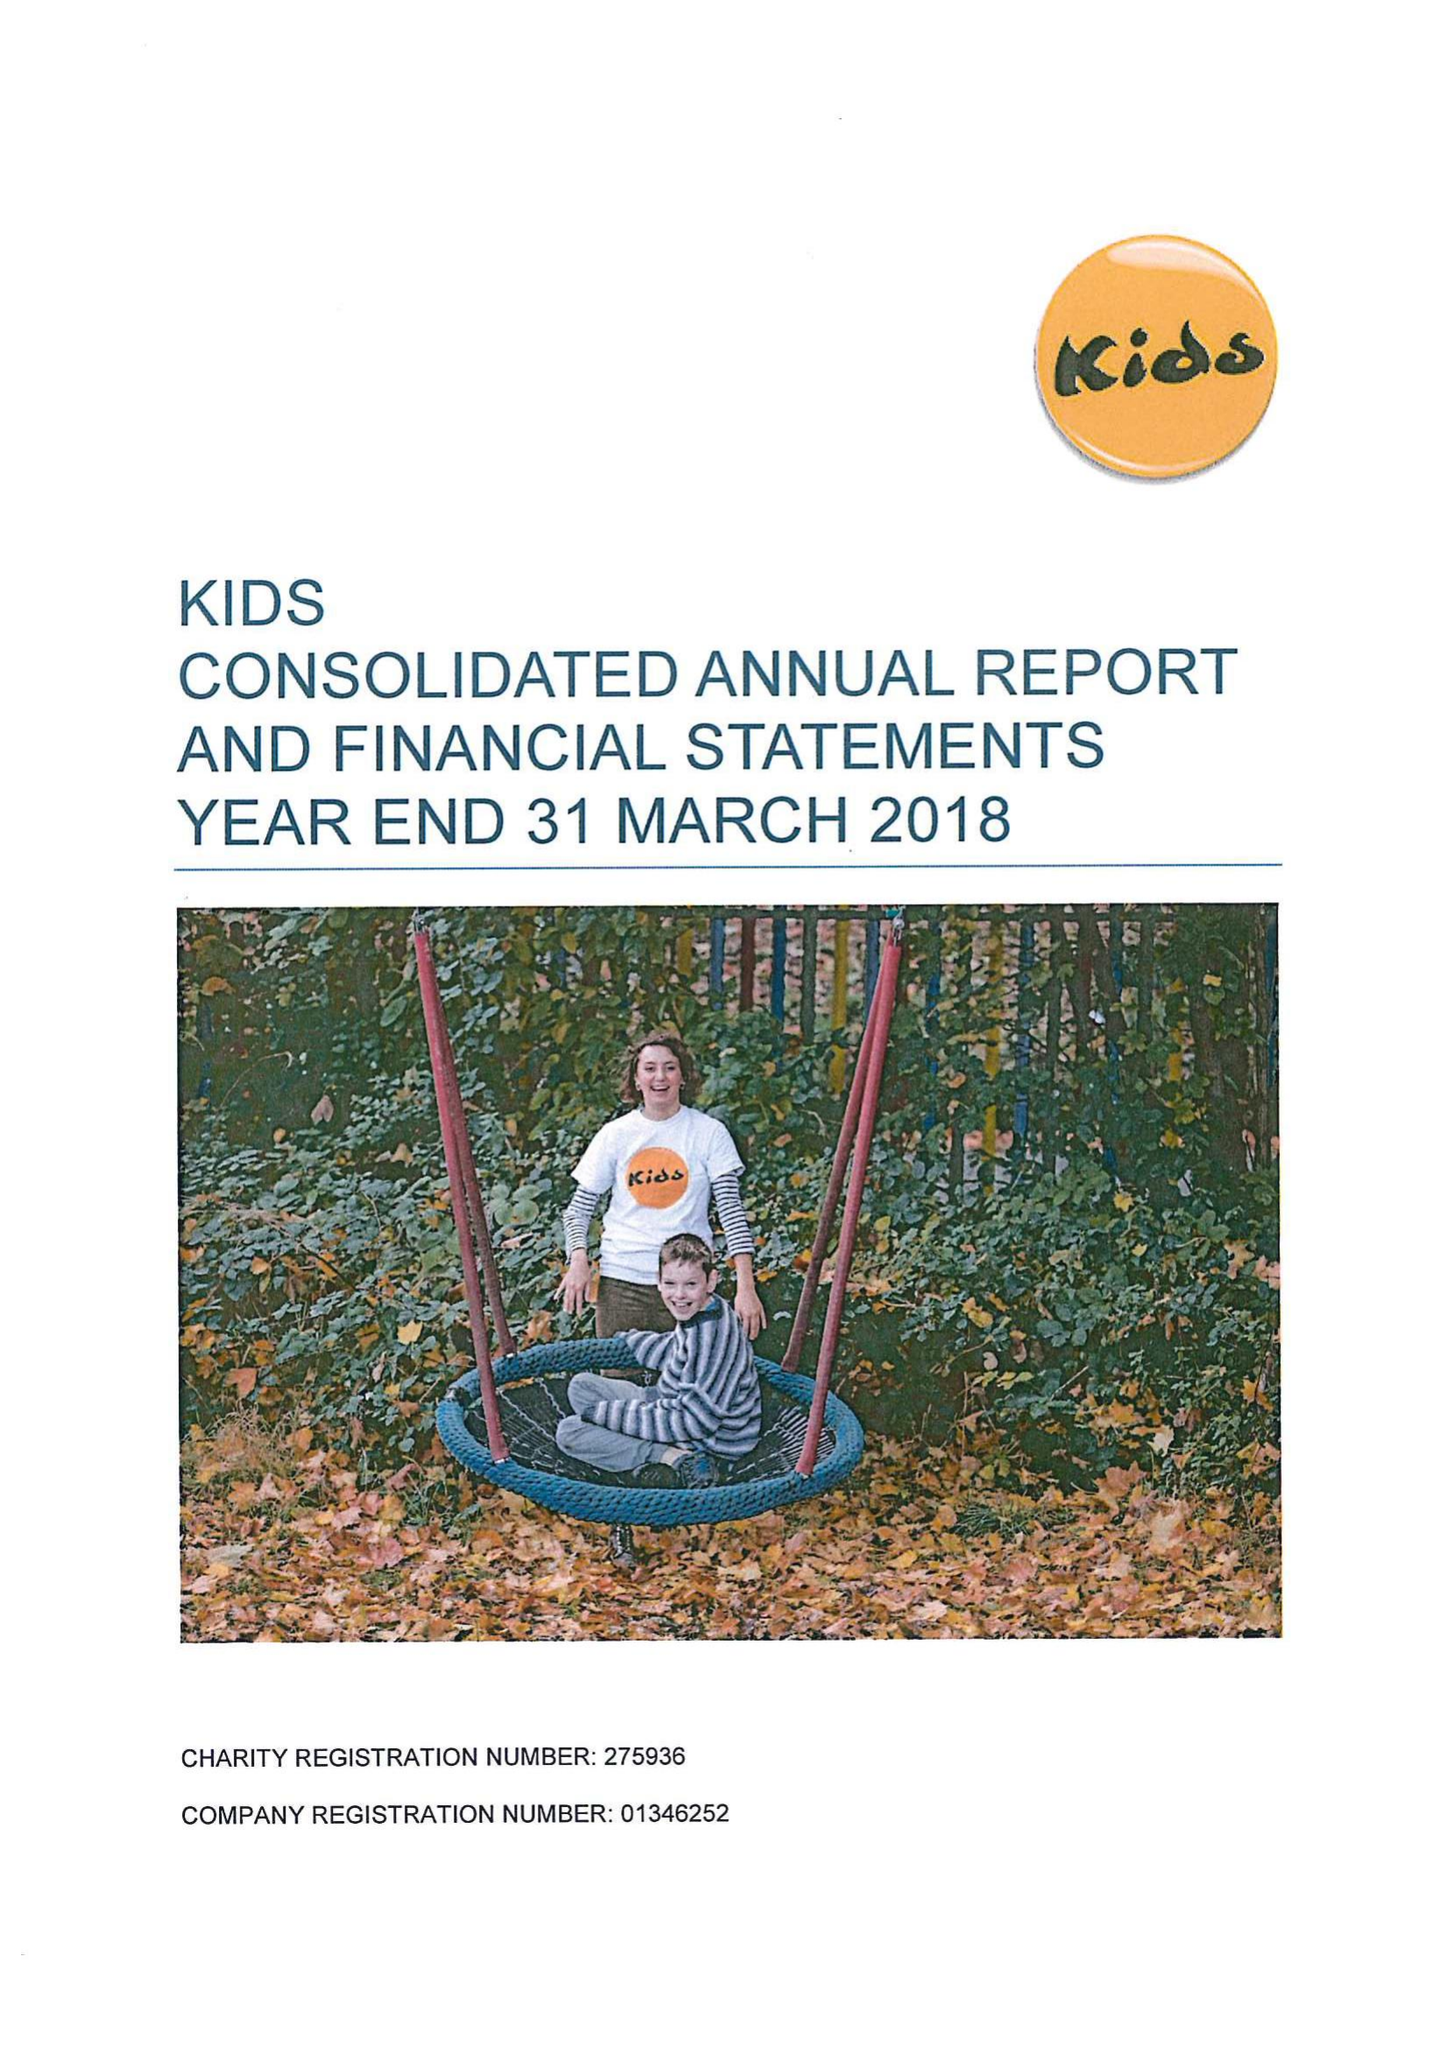What is the value for the report_date?
Answer the question using a single word or phrase. 2018-03-31 